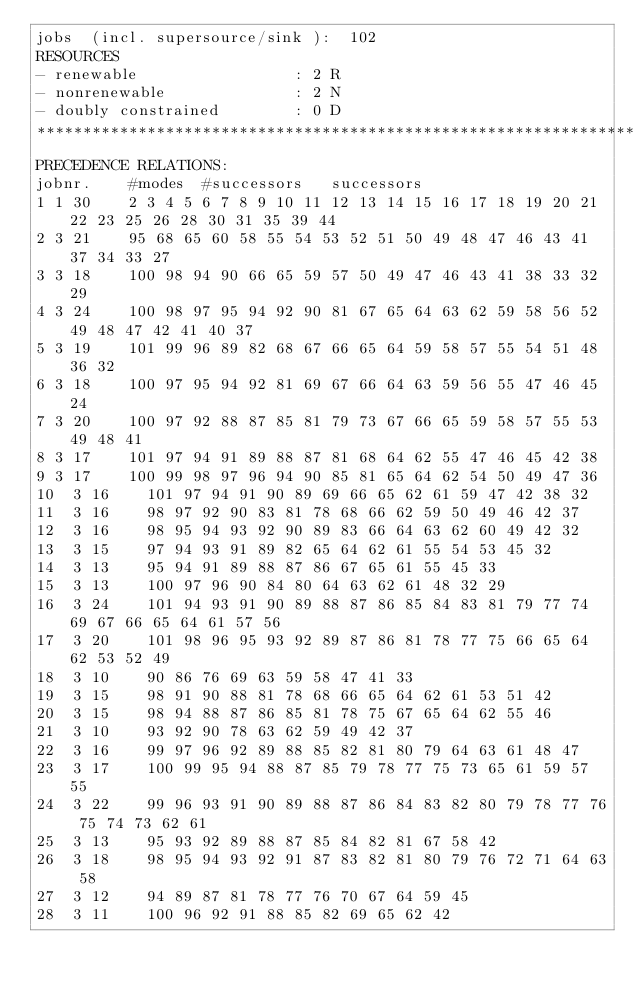Convert code to text. <code><loc_0><loc_0><loc_500><loc_500><_ObjectiveC_>jobs  (incl. supersource/sink ):	102
RESOURCES
- renewable                 : 2 R
- nonrenewable              : 2 N
- doubly constrained        : 0 D
************************************************************************
PRECEDENCE RELATIONS:
jobnr.    #modes  #successors   successors
1	1	30		2 3 4 5 6 7 8 9 10 11 12 13 14 15 16 17 18 19 20 21 22 23 25 26 28 30 31 35 39 44 
2	3	21		95 68 65 60 58 55 54 53 52 51 50 49 48 47 46 43 41 37 34 33 27 
3	3	18		100 98 94 90 66 65 59 57 50 49 47 46 43 41 38 33 32 29 
4	3	24		100 98 97 95 94 92 90 81 67 65 64 63 62 59 58 56 52 49 48 47 42 41 40 37 
5	3	19		101 99 96 89 82 68 67 66 65 64 59 58 57 55 54 51 48 36 32 
6	3	18		100 97 95 94 92 81 69 67 66 64 63 59 56 55 47 46 45 24 
7	3	20		100 97 92 88 87 85 81 79 73 67 66 65 59 58 57 55 53 49 48 41 
8	3	17		101 97 94 91 89 88 87 81 68 64 62 55 47 46 45 42 38 
9	3	17		100 99 98 97 96 94 90 85 81 65 64 62 54 50 49 47 36 
10	3	16		101 97 94 91 90 89 69 66 65 62 61 59 47 42 38 32 
11	3	16		98 97 92 90 83 81 78 68 66 62 59 50 49 46 42 37 
12	3	16		98 95 94 93 92 90 89 83 66 64 63 62 60 49 42 32 
13	3	15		97 94 93 91 89 82 65 64 62 61 55 54 53 45 32 
14	3	13		95 94 91 89 88 87 86 67 65 61 55 45 33 
15	3	13		100 97 96 90 84 80 64 63 62 61 48 32 29 
16	3	24		101 94 93 91 90 89 88 87 86 85 84 83 81 79 77 74 69 67 66 65 64 61 57 56 
17	3	20		101 98 96 95 93 92 89 87 86 81 78 77 75 66 65 64 62 53 52 49 
18	3	10		90 86 76 69 63 59 58 47 41 33 
19	3	15		98 91 90 88 81 78 68 66 65 64 62 61 53 51 42 
20	3	15		98 94 88 87 86 85 81 78 75 67 65 64 62 55 46 
21	3	10		93 92 90 78 63 62 59 49 42 37 
22	3	16		99 97 96 92 89 88 85 82 81 80 79 64 63 61 48 47 
23	3	17		100 99 95 94 88 87 85 79 78 77 75 73 65 61 59 57 55 
24	3	22		99 96 93 91 90 89 88 87 86 84 83 82 80 79 78 77 76 75 74 73 62 61 
25	3	13		95 93 92 89 88 87 85 84 82 81 67 58 42 
26	3	18		98 95 94 93 92 91 87 83 82 81 80 79 76 72 71 64 63 58 
27	3	12		94 89 87 81 78 77 76 70 67 64 59 45 
28	3	11		100 96 92 91 88 85 82 69 65 62 42 </code> 